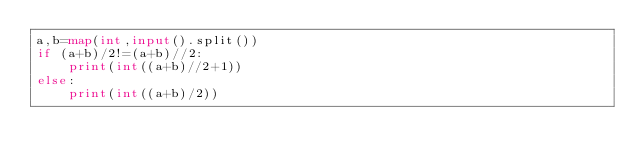Convert code to text. <code><loc_0><loc_0><loc_500><loc_500><_Python_>a,b=map(int,input().split())
if (a+b)/2!=(a+b)//2:
    print(int((a+b)//2+1))
else:
    print(int((a+b)/2))</code> 